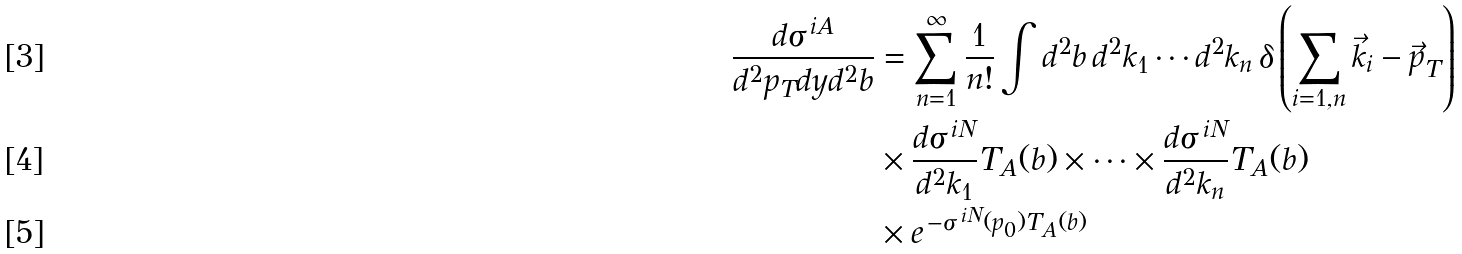<formula> <loc_0><loc_0><loc_500><loc_500>\frac { d \sigma ^ { \, i A } } { d ^ { 2 } p _ { T } d y d ^ { 2 } b } & = \sum _ { n = 1 } ^ { \infty } \frac { 1 } { n ! } \int d ^ { 2 } b \, d ^ { 2 } k _ { 1 } \cdots d ^ { 2 } k _ { n } \, \delta \left ( \sum _ { i = 1 , n } { \vec { k } } _ { i } - { \vec { p } _ { T } } \right ) \\ & \times \frac { d \sigma ^ { \, i N } } { d ^ { 2 } k _ { 1 } } T _ { A } ( b ) \times \dots \times \frac { d \sigma ^ { \, i N } } { d ^ { 2 } k _ { n } } T _ { A } ( b ) \\ & \times e ^ { \, - \sigma ^ { \, i N } ( p _ { 0 } ) T _ { A } ( b ) } \,</formula> 